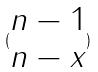<formula> <loc_0><loc_0><loc_500><loc_500>( \begin{matrix} n - 1 \\ n - x \end{matrix} )</formula> 